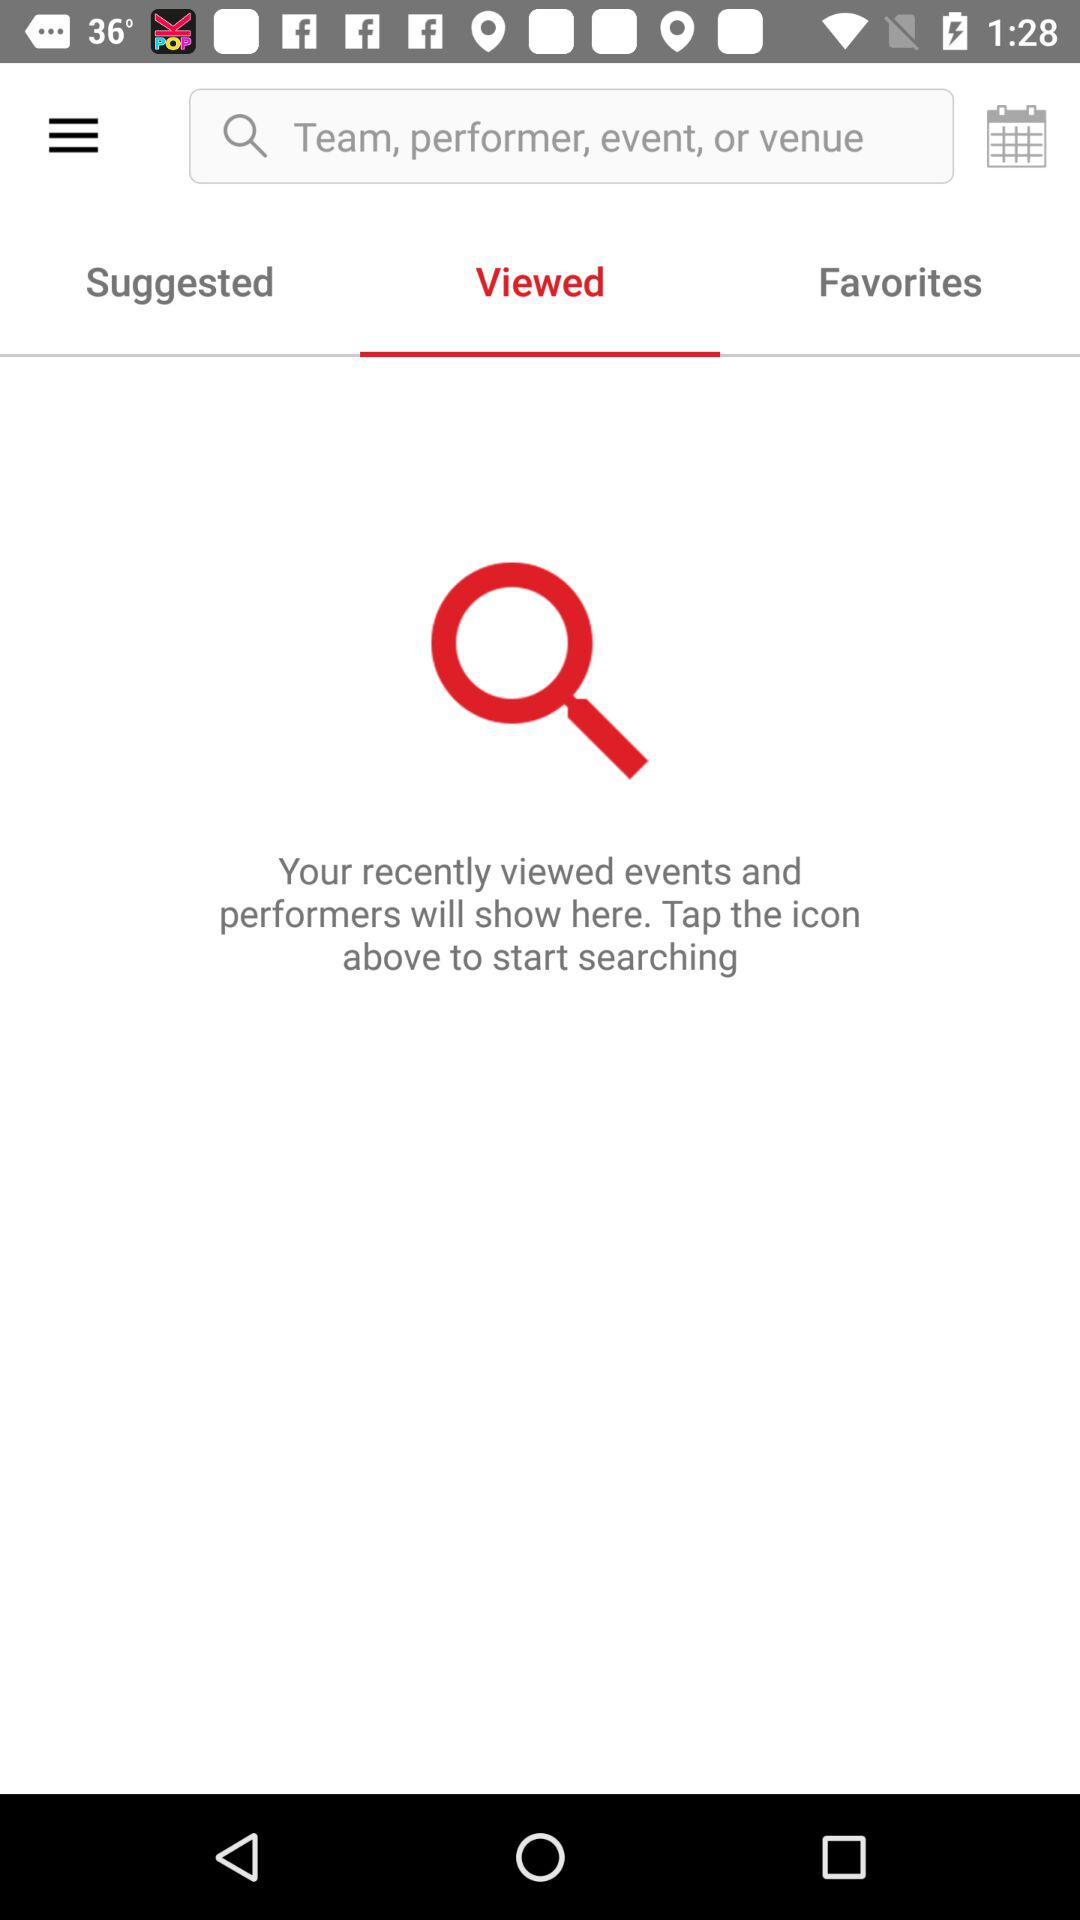Which tab is selected? The selected tab is "Viewed". 